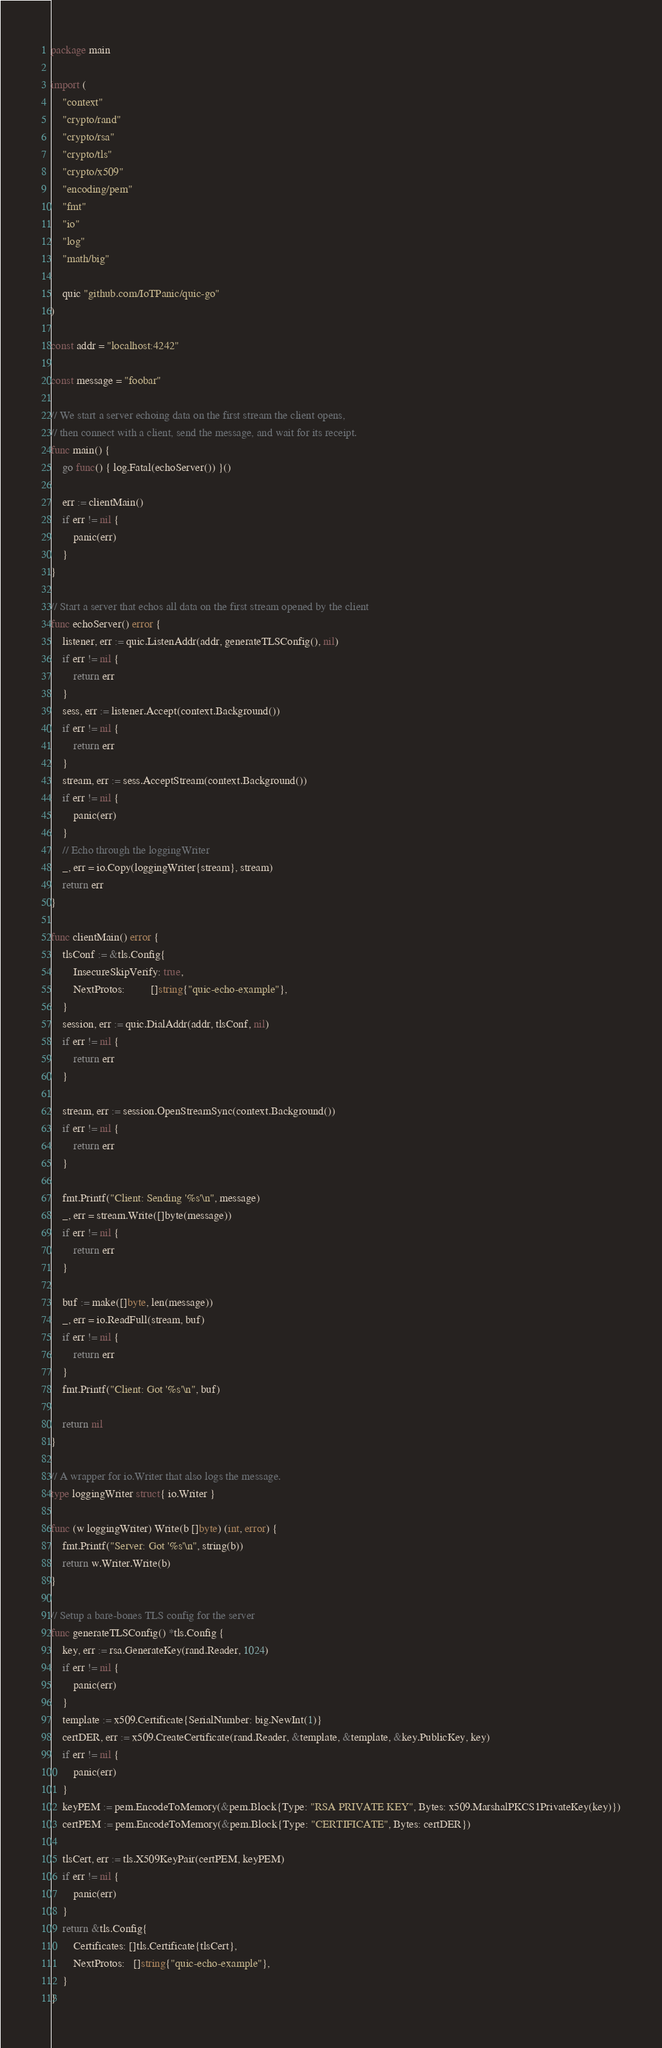Convert code to text. <code><loc_0><loc_0><loc_500><loc_500><_Go_>package main

import (
	"context"
	"crypto/rand"
	"crypto/rsa"
	"crypto/tls"
	"crypto/x509"
	"encoding/pem"
	"fmt"
	"io"
	"log"
	"math/big"

	quic "github.com/IoTPanic/quic-go"
)

const addr = "localhost:4242"

const message = "foobar"

// We start a server echoing data on the first stream the client opens,
// then connect with a client, send the message, and wait for its receipt.
func main() {
	go func() { log.Fatal(echoServer()) }()

	err := clientMain()
	if err != nil {
		panic(err)
	}
}

// Start a server that echos all data on the first stream opened by the client
func echoServer() error {
	listener, err := quic.ListenAddr(addr, generateTLSConfig(), nil)
	if err != nil {
		return err
	}
	sess, err := listener.Accept(context.Background())
	if err != nil {
		return err
	}
	stream, err := sess.AcceptStream(context.Background())
	if err != nil {
		panic(err)
	}
	// Echo through the loggingWriter
	_, err = io.Copy(loggingWriter{stream}, stream)
	return err
}

func clientMain() error {
	tlsConf := &tls.Config{
		InsecureSkipVerify: true,
		NextProtos:         []string{"quic-echo-example"},
	}
	session, err := quic.DialAddr(addr, tlsConf, nil)
	if err != nil {
		return err
	}

	stream, err := session.OpenStreamSync(context.Background())
	if err != nil {
		return err
	}

	fmt.Printf("Client: Sending '%s'\n", message)
	_, err = stream.Write([]byte(message))
	if err != nil {
		return err
	}

	buf := make([]byte, len(message))
	_, err = io.ReadFull(stream, buf)
	if err != nil {
		return err
	}
	fmt.Printf("Client: Got '%s'\n", buf)

	return nil
}

// A wrapper for io.Writer that also logs the message.
type loggingWriter struct{ io.Writer }

func (w loggingWriter) Write(b []byte) (int, error) {
	fmt.Printf("Server: Got '%s'\n", string(b))
	return w.Writer.Write(b)
}

// Setup a bare-bones TLS config for the server
func generateTLSConfig() *tls.Config {
	key, err := rsa.GenerateKey(rand.Reader, 1024)
	if err != nil {
		panic(err)
	}
	template := x509.Certificate{SerialNumber: big.NewInt(1)}
	certDER, err := x509.CreateCertificate(rand.Reader, &template, &template, &key.PublicKey, key)
	if err != nil {
		panic(err)
	}
	keyPEM := pem.EncodeToMemory(&pem.Block{Type: "RSA PRIVATE KEY", Bytes: x509.MarshalPKCS1PrivateKey(key)})
	certPEM := pem.EncodeToMemory(&pem.Block{Type: "CERTIFICATE", Bytes: certDER})

	tlsCert, err := tls.X509KeyPair(certPEM, keyPEM)
	if err != nil {
		panic(err)
	}
	return &tls.Config{
		Certificates: []tls.Certificate{tlsCert},
		NextProtos:   []string{"quic-echo-example"},
	}
}
</code> 